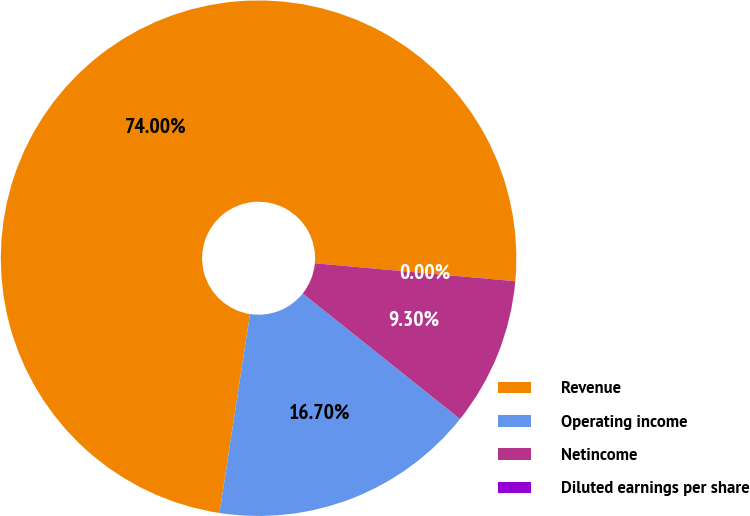Convert chart to OTSL. <chart><loc_0><loc_0><loc_500><loc_500><pie_chart><fcel>Revenue<fcel>Operating income<fcel>Netincome<fcel>Diluted earnings per share<nl><fcel>74.0%<fcel>16.7%<fcel>9.3%<fcel>0.0%<nl></chart> 